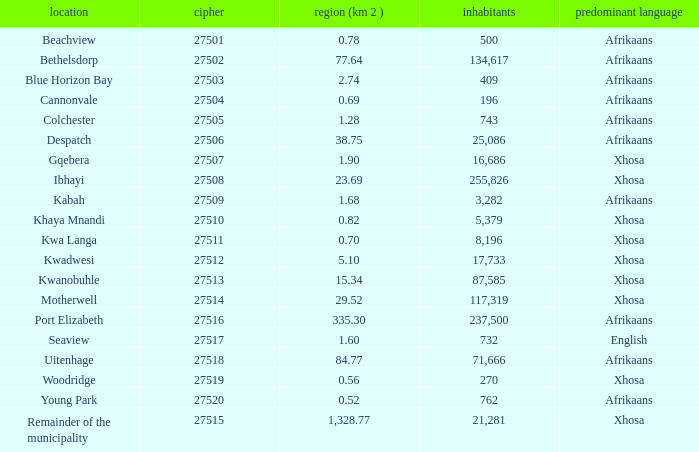What is the lowest area for cannonvale that speaks afrikaans? 0.69. 